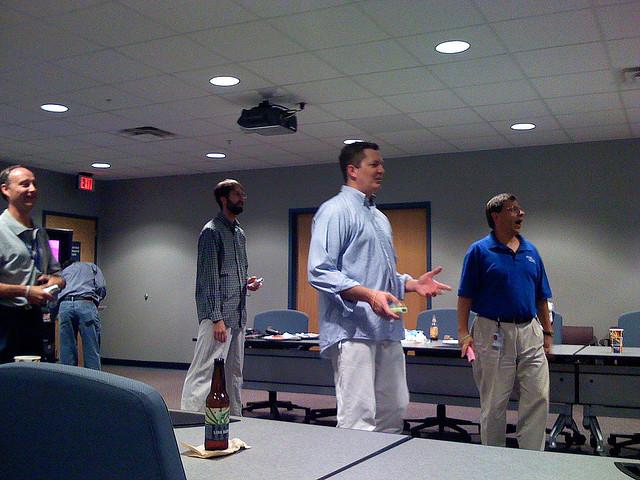What bottle is on the table?
Quick response, please. Beer. Is this a meeting?
Concise answer only. Yes. Are these men standing inside of an office?
Be succinct. Yes. 